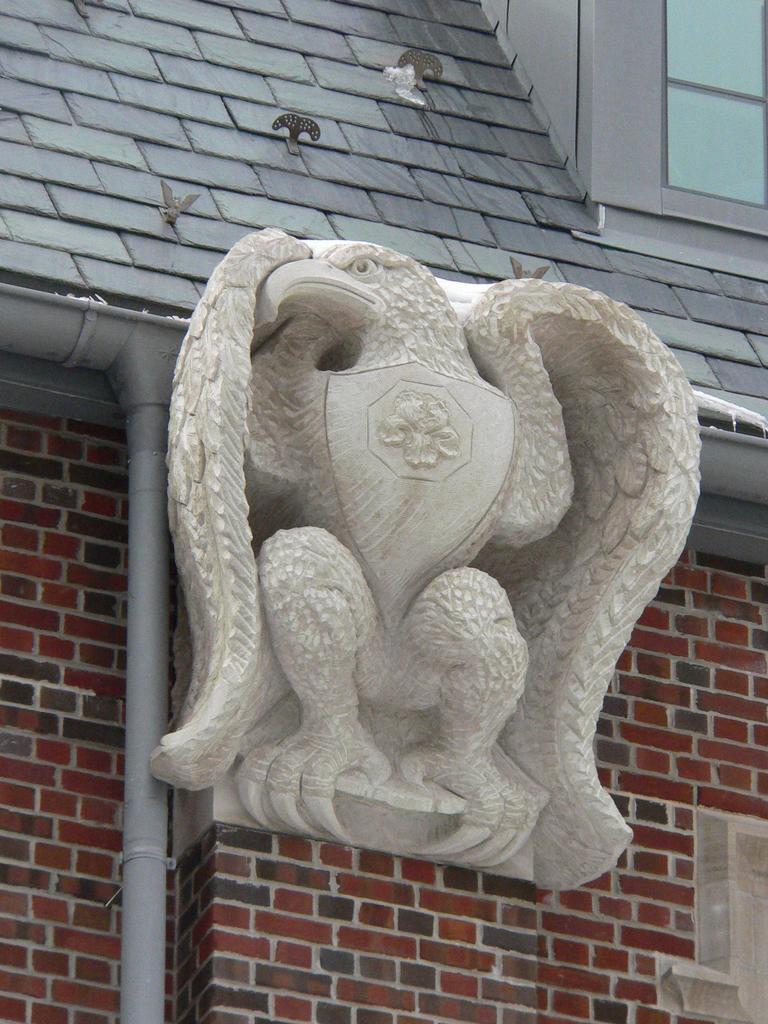Describe this image in one or two sentences. In this picture we can see statue on the wall, pipe, window and objects on the rooftop. 